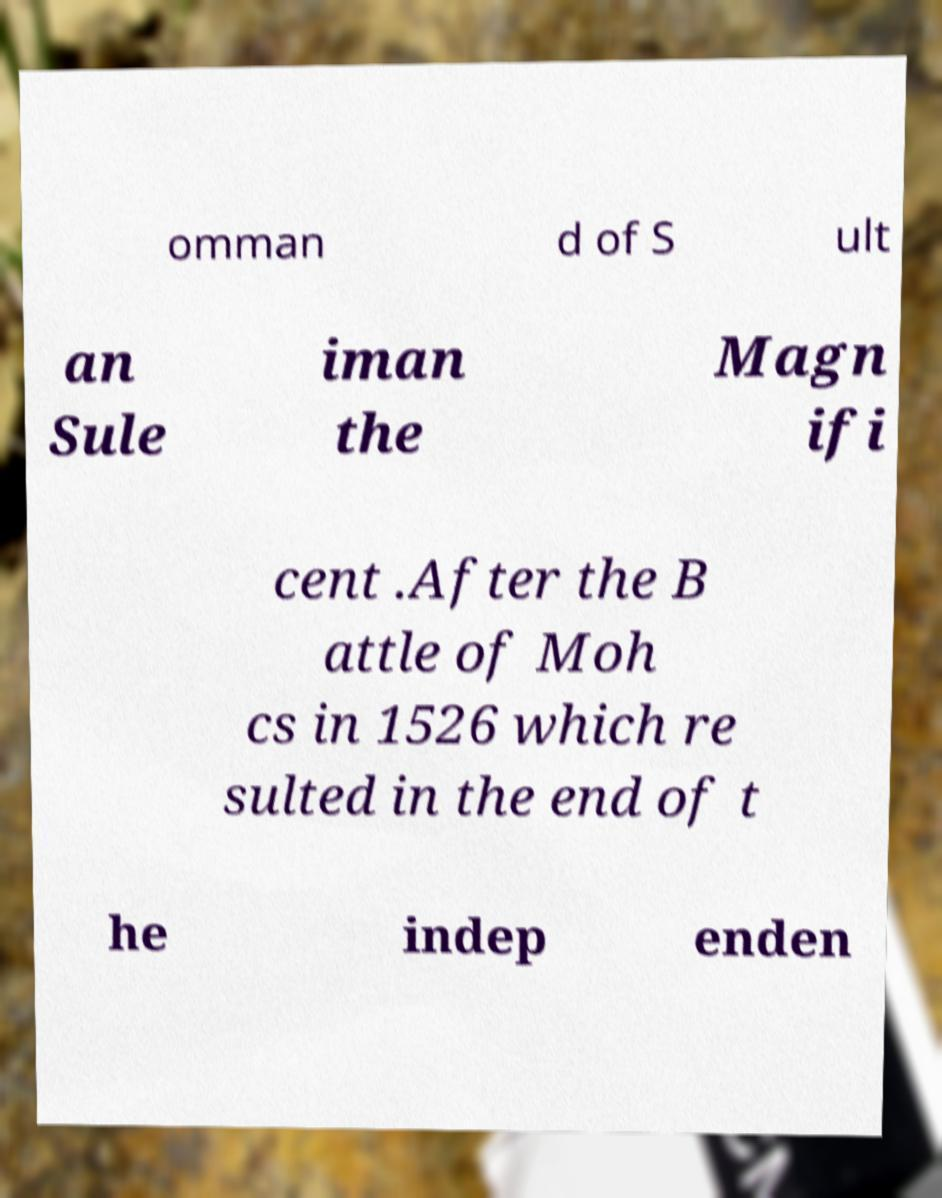Could you assist in decoding the text presented in this image and type it out clearly? omman d of S ult an Sule iman the Magn ifi cent .After the B attle of Moh cs in 1526 which re sulted in the end of t he indep enden 